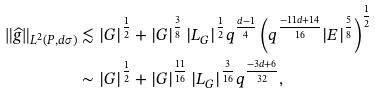Convert formula to latex. <formula><loc_0><loc_0><loc_500><loc_500>\| \widehat { g } \| _ { L ^ { 2 } ( P , d \sigma ) } & \lesssim | G | ^ { \frac { 1 } { 2 } } + | G | ^ { \frac { 3 } { 8 } } \, | L _ { G } | ^ { \frac { 1 } { 2 } } q ^ { \frac { d - 1 } { 4 } } \left ( q ^ { \frac { - 1 1 d + 1 4 } { 1 6 } } | E | ^ { \frac { 5 } { 8 } } \right ) ^ { \frac { 1 } { 2 } } \\ & \sim | G | ^ { \frac { 1 } { 2 } } + | G | ^ { \frac { 1 1 } { 1 6 } } \, | L _ { G } | ^ { \frac { 3 } { 1 6 } } q ^ { \frac { - 3 d + 6 } { 3 2 } } ,</formula> 